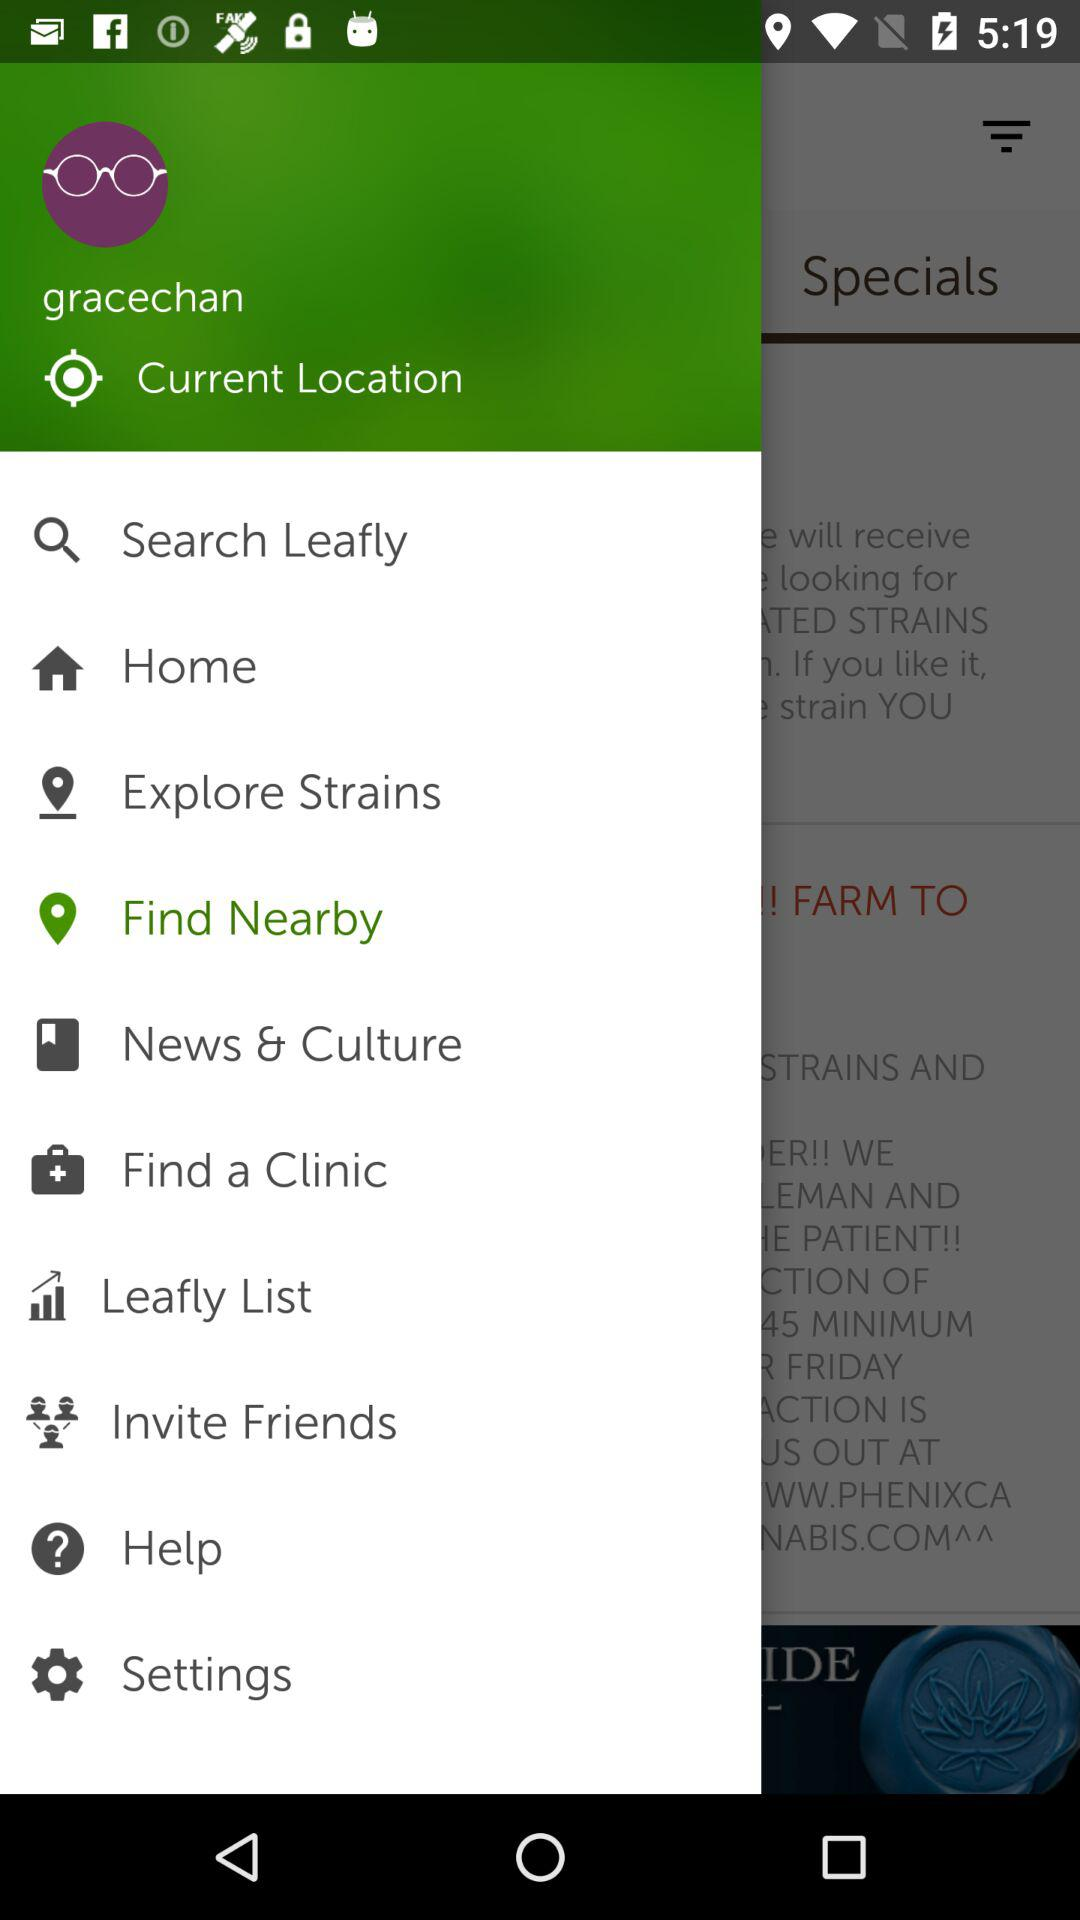What is the name of the user? The name of the user is "gracechan". 